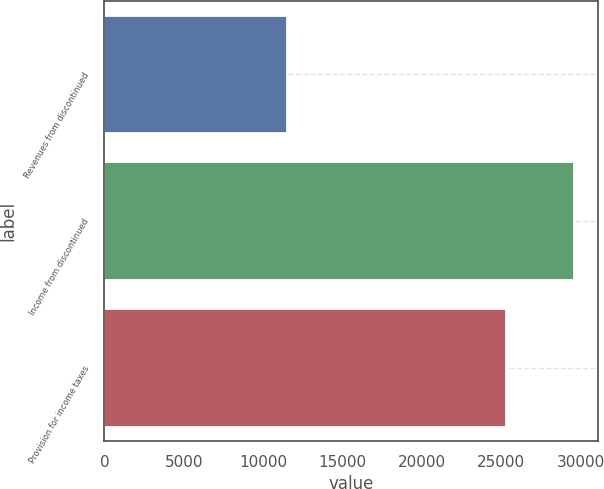Convert chart. <chart><loc_0><loc_0><loc_500><loc_500><bar_chart><fcel>Revenues from discontinued<fcel>Income from discontinued<fcel>Provision for income taxes<nl><fcel>11512<fcel>29602<fcel>25305<nl></chart> 